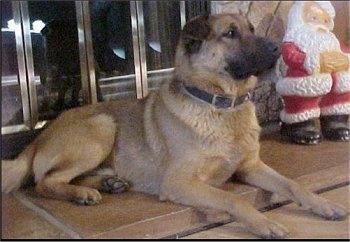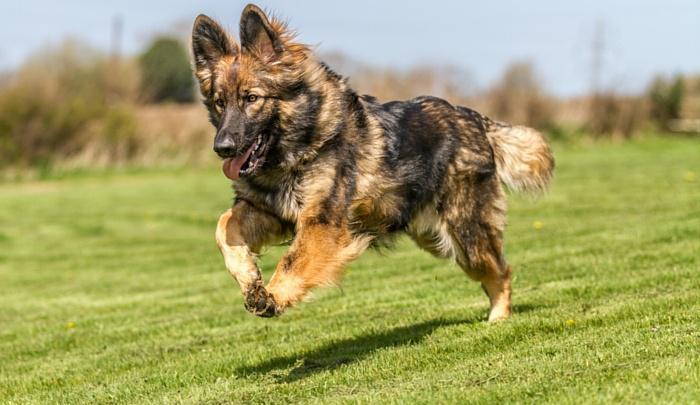The first image is the image on the left, the second image is the image on the right. Evaluate the accuracy of this statement regarding the images: "At least one of the dogs is indoors.". Is it true? Answer yes or no. Yes. The first image is the image on the left, the second image is the image on the right. Examine the images to the left and right. Is the description "In one image a dog is lying down on a raised surface." accurate? Answer yes or no. Yes. 